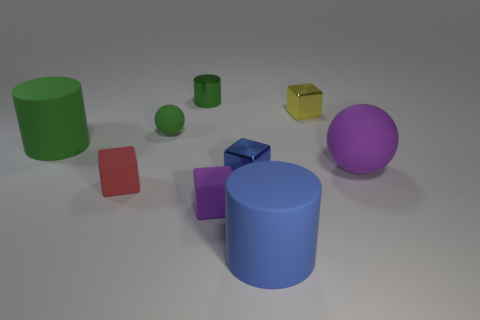Subtract all blue balls. Subtract all red blocks. How many balls are left? 2 Subtract all cyan balls. How many red cylinders are left? 0 Add 3 greens. How many small reds exist? 0 Subtract all small green matte spheres. Subtract all large matte spheres. How many objects are left? 7 Add 7 cylinders. How many cylinders are left? 10 Add 8 large yellow shiny objects. How many large yellow shiny objects exist? 8 Add 1 gray metal balls. How many objects exist? 10 Subtract all green cylinders. How many cylinders are left? 1 Subtract all small purple matte blocks. How many blocks are left? 3 Subtract 0 cyan cubes. How many objects are left? 9 